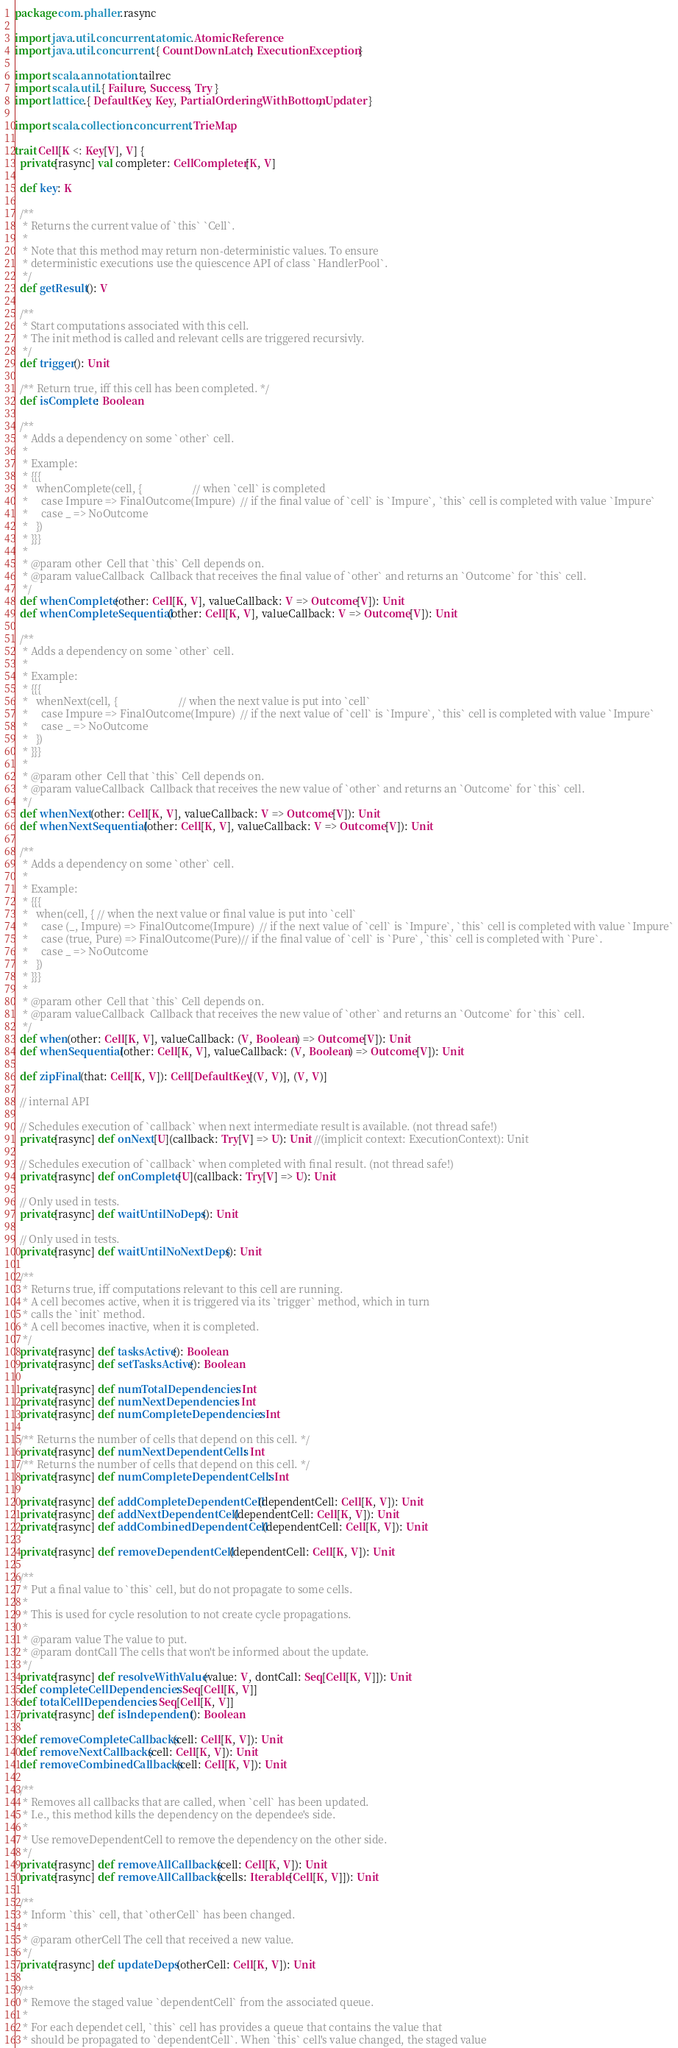Convert code to text. <code><loc_0><loc_0><loc_500><loc_500><_Scala_>package com.phaller.rasync

import java.util.concurrent.atomic.AtomicReference
import java.util.concurrent.{ CountDownLatch, ExecutionException }

import scala.annotation.tailrec
import scala.util.{ Failure, Success, Try }
import lattice.{ DefaultKey, Key, PartialOrderingWithBottom, Updater }

import scala.collection.concurrent.TrieMap

trait Cell[K <: Key[V], V] {
  private[rasync] val completer: CellCompleter[K, V]

  def key: K

  /**
   * Returns the current value of `this` `Cell`.
   *
   * Note that this method may return non-deterministic values. To ensure
   * deterministic executions use the quiescence API of class `HandlerPool`.
   */
  def getResult(): V

  /**
   * Start computations associated with this cell.
   * The init method is called and relevant cells are triggered recursivly.
   */
  def trigger(): Unit

  /** Return true, iff this cell has been completed. */
  def isComplete: Boolean

  /**
   * Adds a dependency on some `other` cell.
   *
   * Example:
   * {{{
   *   whenComplete(cell, {                   // when `cell` is completed
   *     case Impure => FinalOutcome(Impure)  // if the final value of `cell` is `Impure`, `this` cell is completed with value `Impure`
   *     case _ => NoOutcome
   *   })
   * }}}
   *
   * @param other  Cell that `this` Cell depends on.
   * @param valueCallback  Callback that receives the final value of `other` and returns an `Outcome` for `this` cell.
   */
  def whenComplete(other: Cell[K, V], valueCallback: V => Outcome[V]): Unit
  def whenCompleteSequential(other: Cell[K, V], valueCallback: V => Outcome[V]): Unit

  /**
   * Adds a dependency on some `other` cell.
   *
   * Example:
   * {{{
   *   whenNext(cell, {                       // when the next value is put into `cell`
   *     case Impure => FinalOutcome(Impure)  // if the next value of `cell` is `Impure`, `this` cell is completed with value `Impure`
   *     case _ => NoOutcome
   *   })
   * }}}
   *
   * @param other  Cell that `this` Cell depends on.
   * @param valueCallback  Callback that receives the new value of `other` and returns an `Outcome` for `this` cell.
   */
  def whenNext(other: Cell[K, V], valueCallback: V => Outcome[V]): Unit
  def whenNextSequential(other: Cell[K, V], valueCallback: V => Outcome[V]): Unit

  /**
   * Adds a dependency on some `other` cell.
   *
   * Example:
   * {{{
   *   when(cell, { // when the next value or final value is put into `cell`
   *     case (_, Impure) => FinalOutcome(Impure)  // if the next value of `cell` is `Impure`, `this` cell is completed with value `Impure`
   *     case (true, Pure) => FinalOutcome(Pure)// if the final value of `cell` is `Pure`, `this` cell is completed with `Pure`.
   *     case _ => NoOutcome
   *   })
   * }}}
   *
   * @param other  Cell that `this` Cell depends on.
   * @param valueCallback  Callback that receives the new value of `other` and returns an `Outcome` for `this` cell.
   */
  def when(other: Cell[K, V], valueCallback: (V, Boolean) => Outcome[V]): Unit
  def whenSequential(other: Cell[K, V], valueCallback: (V, Boolean) => Outcome[V]): Unit

  def zipFinal(that: Cell[K, V]): Cell[DefaultKey[(V, V)], (V, V)]

  // internal API

  // Schedules execution of `callback` when next intermediate result is available. (not thread safe!)
  private[rasync] def onNext[U](callback: Try[V] => U): Unit //(implicit context: ExecutionContext): Unit

  // Schedules execution of `callback` when completed with final result. (not thread safe!)
  private[rasync] def onComplete[U](callback: Try[V] => U): Unit

  // Only used in tests.
  private[rasync] def waitUntilNoDeps(): Unit

  // Only used in tests.
  private[rasync] def waitUntilNoNextDeps(): Unit

  /**
   * Returns true, iff computations relevant to this cell are running.
   * A cell becomes active, when it is triggered via its `trigger` method, which in turn
   * calls the `init` method.
   * A cell becomes inactive, when it is completed.
   */
  private[rasync] def tasksActive(): Boolean
  private[rasync] def setTasksActive(): Boolean

  private[rasync] def numTotalDependencies: Int
  private[rasync] def numNextDependencies: Int
  private[rasync] def numCompleteDependencies: Int

  /** Returns the number of cells that depend on this cell. */
  private[rasync] def numNextDependentCells: Int
  /** Returns the number of cells that depend on this cell. */
  private[rasync] def numCompleteDependentCells: Int

  private[rasync] def addCompleteDependentCell(dependentCell: Cell[K, V]): Unit
  private[rasync] def addNextDependentCell(dependentCell: Cell[K, V]): Unit
  private[rasync] def addCombinedDependentCell(dependentCell: Cell[K, V]): Unit

  private[rasync] def removeDependentCell(dependentCell: Cell[K, V]): Unit

  /**
   * Put a final value to `this` cell, but do not propagate to some cells.
   *
   * This is used for cycle resolution to not create cycle propagations.
   *
   * @param value The value to put.
   * @param dontCall The cells that won't be informed about the update.
   */
  private[rasync] def resolveWithValue(value: V, dontCall: Seq[Cell[K, V]]): Unit
  def completeCellDependencies: Seq[Cell[K, V]]
  def totalCellDependencies: Seq[Cell[K, V]]
  private[rasync] def isIndependent(): Boolean

  def removeCompleteCallbacks(cell: Cell[K, V]): Unit
  def removeNextCallbacks(cell: Cell[K, V]): Unit
  def removeCombinedCallbacks(cell: Cell[K, V]): Unit

  /**
   * Removes all callbacks that are called, when `cell` has been updated.
   * I.e., this method kills the dependency on the dependee's side.
   *
   * Use removeDependentCell to remove the dependency on the other side.
   */
  private[rasync] def removeAllCallbacks(cell: Cell[K, V]): Unit
  private[rasync] def removeAllCallbacks(cells: Iterable[Cell[K, V]]): Unit

  /**
   * Inform `this` cell, that `otherCell` has been changed.
   *
   * @param otherCell The cell that received a new value.
   */
  private[rasync] def updateDeps(otherCell: Cell[K, V]): Unit

  /**
   * Remove the staged value `dependentCell` from the associated queue.
   *
   * For each dependet cell, `this` cell has provides a queue that contains the value that
   * should be propagated to `dependentCell`. When `this` cell's value changed, the staged value</code> 